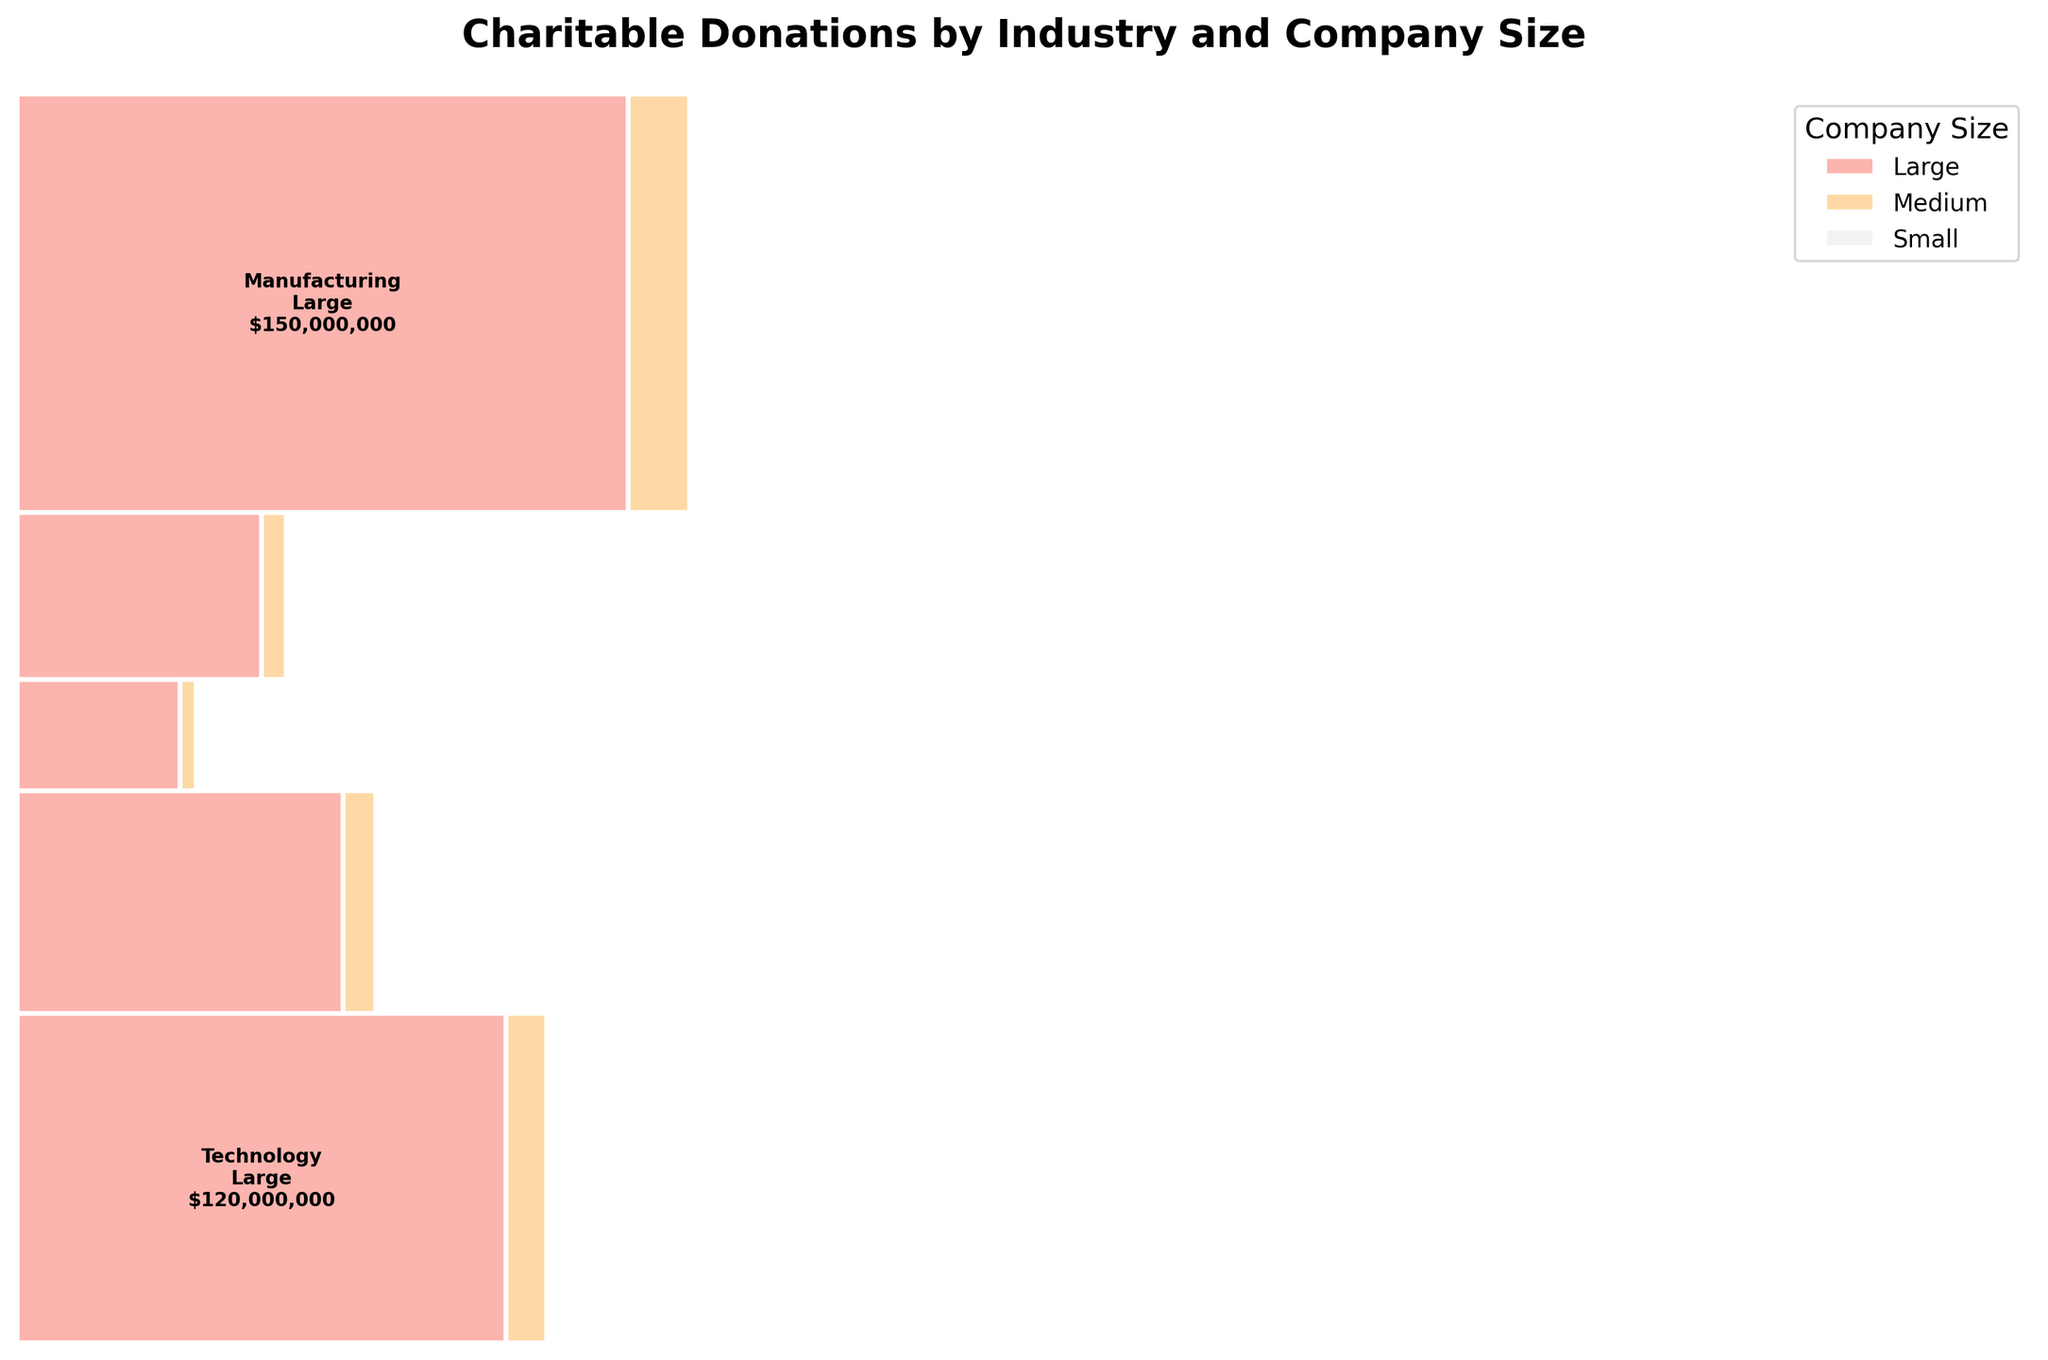Which industry donates the most overall? By looking at the heights of the rectangles for each industry, we see that Technology has the largest total area, indicating the highest donations.
Answer: Technology Which company size contributes the least donation amount in Healthcare? In Healthcare, the smallest rectangle (and thus the least donation amount) among the company sizes is for Small companies.
Answer: Small How do the donations from Medium-sized Finance companies compare to those from Medium-sized Retail companies? By comparing the rectangles' areas or labels, we see that Medium-sized Finance companies donate more than Medium-sized Retail companies.
Answer: Finance contributes more What is the total donation amount from Small companies across all industries? Summing up the donation amounts listed for Small companies: 500,000 (Tech) + 300,000 (Finance) + 200,000 (Healthcare) + 150,000 (Retail) + 100,000 (Manufacturing) = 1,250,000.
Answer: 1,250,000 Which Industry has the highest donation amount from Large companies? By looking at the largest rectangles for Large companies, Technology stands out with the biggest section.
Answer: Technology Are Medium-sized companies in Retail donating more than Medium-sized companies in Manufacturing? Comparing the areas or labels of Medium-sized Retail and Manufacturing shows that Retail companies donate more.
Answer: Yes How does the donation from Large Healthcare companies compare to that from Large Manufacturing companies? By comparing the areas or labels, we see that Large Healthcare companies donate significantly more than Large Manufacturing companies.
Answer: Healthcare donates more What proportion of the total donation amount is contributed by Large companies in the Finance industry? The donation amount is $120,000,000. The total donation amount from all companies is $418,850,000. The proportion is 120,000,000 / 418,850,000 ≈ 0.286 (28.6%).
Answer: 28.6% Which sector has the smallest donations across all company sizes? By comparing rectangles across industries, Manufacturing has the smallest total area, indicating the lowest overall donations.
Answer: Manufacturing What is the combined donation amount from Large and Medium Healthcare companies? Summing up the donation amounts listed for Large and Medium Healthcare companies: 80,000,000 + 8,000,000 = 88,000,000.
Answer: 88,000,000 